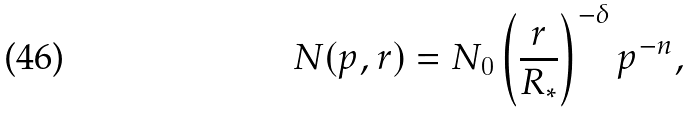<formula> <loc_0><loc_0><loc_500><loc_500>N ( p , r ) = N _ { 0 } \left ( \frac { r } { R _ { * } } \right ) ^ { - \delta } p ^ { - n } ,</formula> 